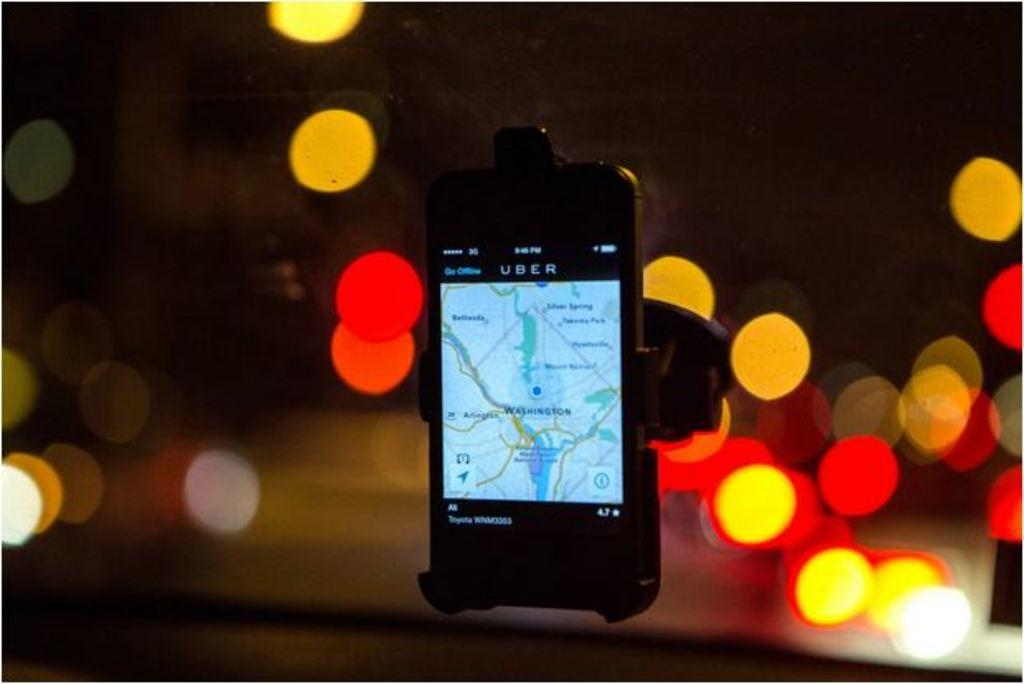<image>
Summarize the visual content of the image. A phone on a car holder with Uber on title of the screen 